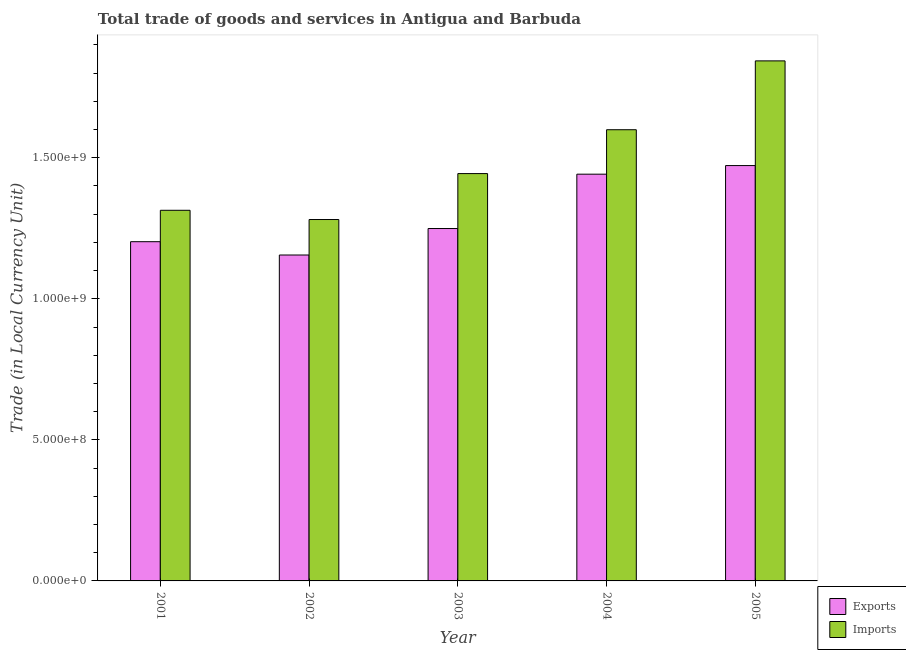How many groups of bars are there?
Offer a terse response. 5. Are the number of bars per tick equal to the number of legend labels?
Your response must be concise. Yes. Are the number of bars on each tick of the X-axis equal?
Make the answer very short. Yes. What is the export of goods and services in 2001?
Ensure brevity in your answer.  1.20e+09. Across all years, what is the maximum imports of goods and services?
Ensure brevity in your answer.  1.84e+09. Across all years, what is the minimum export of goods and services?
Give a very brief answer. 1.16e+09. In which year was the imports of goods and services maximum?
Keep it short and to the point. 2005. What is the total export of goods and services in the graph?
Ensure brevity in your answer.  6.52e+09. What is the difference between the imports of goods and services in 2001 and that in 2004?
Ensure brevity in your answer.  -2.86e+08. What is the difference between the export of goods and services in 2002 and the imports of goods and services in 2004?
Keep it short and to the point. -2.86e+08. What is the average imports of goods and services per year?
Ensure brevity in your answer.  1.50e+09. In the year 2001, what is the difference between the export of goods and services and imports of goods and services?
Make the answer very short. 0. In how many years, is the imports of goods and services greater than 600000000 LCU?
Your answer should be very brief. 5. What is the ratio of the export of goods and services in 2001 to that in 2002?
Offer a very short reply. 1.04. Is the difference between the export of goods and services in 2003 and 2004 greater than the difference between the imports of goods and services in 2003 and 2004?
Provide a short and direct response. No. What is the difference between the highest and the second highest imports of goods and services?
Your answer should be very brief. 2.44e+08. What is the difference between the highest and the lowest imports of goods and services?
Ensure brevity in your answer.  5.62e+08. In how many years, is the imports of goods and services greater than the average imports of goods and services taken over all years?
Give a very brief answer. 2. What does the 2nd bar from the left in 2005 represents?
Provide a succinct answer. Imports. What does the 2nd bar from the right in 2003 represents?
Provide a succinct answer. Exports. Are all the bars in the graph horizontal?
Offer a very short reply. No. How many years are there in the graph?
Keep it short and to the point. 5. How many legend labels are there?
Provide a short and direct response. 2. How are the legend labels stacked?
Offer a terse response. Vertical. What is the title of the graph?
Offer a very short reply. Total trade of goods and services in Antigua and Barbuda. What is the label or title of the X-axis?
Provide a succinct answer. Year. What is the label or title of the Y-axis?
Keep it short and to the point. Trade (in Local Currency Unit). What is the Trade (in Local Currency Unit) of Exports in 2001?
Your response must be concise. 1.20e+09. What is the Trade (in Local Currency Unit) of Imports in 2001?
Your response must be concise. 1.31e+09. What is the Trade (in Local Currency Unit) of Exports in 2002?
Make the answer very short. 1.16e+09. What is the Trade (in Local Currency Unit) of Imports in 2002?
Offer a very short reply. 1.28e+09. What is the Trade (in Local Currency Unit) of Exports in 2003?
Provide a short and direct response. 1.25e+09. What is the Trade (in Local Currency Unit) in Imports in 2003?
Provide a succinct answer. 1.44e+09. What is the Trade (in Local Currency Unit) of Exports in 2004?
Provide a succinct answer. 1.44e+09. What is the Trade (in Local Currency Unit) in Imports in 2004?
Provide a short and direct response. 1.60e+09. What is the Trade (in Local Currency Unit) in Exports in 2005?
Provide a short and direct response. 1.47e+09. What is the Trade (in Local Currency Unit) in Imports in 2005?
Provide a succinct answer. 1.84e+09. Across all years, what is the maximum Trade (in Local Currency Unit) of Exports?
Keep it short and to the point. 1.47e+09. Across all years, what is the maximum Trade (in Local Currency Unit) in Imports?
Offer a very short reply. 1.84e+09. Across all years, what is the minimum Trade (in Local Currency Unit) of Exports?
Provide a succinct answer. 1.16e+09. Across all years, what is the minimum Trade (in Local Currency Unit) in Imports?
Keep it short and to the point. 1.28e+09. What is the total Trade (in Local Currency Unit) of Exports in the graph?
Your answer should be very brief. 6.52e+09. What is the total Trade (in Local Currency Unit) of Imports in the graph?
Keep it short and to the point. 7.48e+09. What is the difference between the Trade (in Local Currency Unit) in Exports in 2001 and that in 2002?
Provide a succinct answer. 4.72e+07. What is the difference between the Trade (in Local Currency Unit) of Imports in 2001 and that in 2002?
Ensure brevity in your answer.  3.28e+07. What is the difference between the Trade (in Local Currency Unit) in Exports in 2001 and that in 2003?
Your response must be concise. -4.67e+07. What is the difference between the Trade (in Local Currency Unit) in Imports in 2001 and that in 2003?
Give a very brief answer. -1.30e+08. What is the difference between the Trade (in Local Currency Unit) of Exports in 2001 and that in 2004?
Give a very brief answer. -2.39e+08. What is the difference between the Trade (in Local Currency Unit) of Imports in 2001 and that in 2004?
Offer a very short reply. -2.86e+08. What is the difference between the Trade (in Local Currency Unit) of Exports in 2001 and that in 2005?
Your answer should be compact. -2.70e+08. What is the difference between the Trade (in Local Currency Unit) in Imports in 2001 and that in 2005?
Offer a very short reply. -5.30e+08. What is the difference between the Trade (in Local Currency Unit) of Exports in 2002 and that in 2003?
Offer a very short reply. -9.39e+07. What is the difference between the Trade (in Local Currency Unit) in Imports in 2002 and that in 2003?
Your answer should be compact. -1.63e+08. What is the difference between the Trade (in Local Currency Unit) of Exports in 2002 and that in 2004?
Offer a very short reply. -2.86e+08. What is the difference between the Trade (in Local Currency Unit) in Imports in 2002 and that in 2004?
Give a very brief answer. -3.18e+08. What is the difference between the Trade (in Local Currency Unit) of Exports in 2002 and that in 2005?
Your response must be concise. -3.17e+08. What is the difference between the Trade (in Local Currency Unit) of Imports in 2002 and that in 2005?
Ensure brevity in your answer.  -5.62e+08. What is the difference between the Trade (in Local Currency Unit) of Exports in 2003 and that in 2004?
Make the answer very short. -1.93e+08. What is the difference between the Trade (in Local Currency Unit) in Imports in 2003 and that in 2004?
Ensure brevity in your answer.  -1.55e+08. What is the difference between the Trade (in Local Currency Unit) in Exports in 2003 and that in 2005?
Provide a short and direct response. -2.23e+08. What is the difference between the Trade (in Local Currency Unit) in Imports in 2003 and that in 2005?
Your response must be concise. -4.00e+08. What is the difference between the Trade (in Local Currency Unit) of Exports in 2004 and that in 2005?
Give a very brief answer. -3.05e+07. What is the difference between the Trade (in Local Currency Unit) of Imports in 2004 and that in 2005?
Keep it short and to the point. -2.44e+08. What is the difference between the Trade (in Local Currency Unit) of Exports in 2001 and the Trade (in Local Currency Unit) of Imports in 2002?
Offer a terse response. -7.86e+07. What is the difference between the Trade (in Local Currency Unit) of Exports in 2001 and the Trade (in Local Currency Unit) of Imports in 2003?
Your answer should be compact. -2.41e+08. What is the difference between the Trade (in Local Currency Unit) of Exports in 2001 and the Trade (in Local Currency Unit) of Imports in 2004?
Provide a succinct answer. -3.97e+08. What is the difference between the Trade (in Local Currency Unit) of Exports in 2001 and the Trade (in Local Currency Unit) of Imports in 2005?
Your answer should be very brief. -6.41e+08. What is the difference between the Trade (in Local Currency Unit) of Exports in 2002 and the Trade (in Local Currency Unit) of Imports in 2003?
Your answer should be very brief. -2.89e+08. What is the difference between the Trade (in Local Currency Unit) in Exports in 2002 and the Trade (in Local Currency Unit) in Imports in 2004?
Ensure brevity in your answer.  -4.44e+08. What is the difference between the Trade (in Local Currency Unit) of Exports in 2002 and the Trade (in Local Currency Unit) of Imports in 2005?
Provide a short and direct response. -6.88e+08. What is the difference between the Trade (in Local Currency Unit) of Exports in 2003 and the Trade (in Local Currency Unit) of Imports in 2004?
Provide a short and direct response. -3.50e+08. What is the difference between the Trade (in Local Currency Unit) in Exports in 2003 and the Trade (in Local Currency Unit) in Imports in 2005?
Your answer should be very brief. -5.94e+08. What is the difference between the Trade (in Local Currency Unit) in Exports in 2004 and the Trade (in Local Currency Unit) in Imports in 2005?
Your answer should be compact. -4.02e+08. What is the average Trade (in Local Currency Unit) in Exports per year?
Provide a short and direct response. 1.30e+09. What is the average Trade (in Local Currency Unit) in Imports per year?
Provide a short and direct response. 1.50e+09. In the year 2001, what is the difference between the Trade (in Local Currency Unit) of Exports and Trade (in Local Currency Unit) of Imports?
Offer a very short reply. -1.11e+08. In the year 2002, what is the difference between the Trade (in Local Currency Unit) of Exports and Trade (in Local Currency Unit) of Imports?
Provide a short and direct response. -1.26e+08. In the year 2003, what is the difference between the Trade (in Local Currency Unit) in Exports and Trade (in Local Currency Unit) in Imports?
Your answer should be compact. -1.95e+08. In the year 2004, what is the difference between the Trade (in Local Currency Unit) in Exports and Trade (in Local Currency Unit) in Imports?
Provide a short and direct response. -1.58e+08. In the year 2005, what is the difference between the Trade (in Local Currency Unit) in Exports and Trade (in Local Currency Unit) in Imports?
Provide a short and direct response. -3.71e+08. What is the ratio of the Trade (in Local Currency Unit) of Exports in 2001 to that in 2002?
Your answer should be very brief. 1.04. What is the ratio of the Trade (in Local Currency Unit) of Imports in 2001 to that in 2002?
Provide a succinct answer. 1.03. What is the ratio of the Trade (in Local Currency Unit) of Exports in 2001 to that in 2003?
Your answer should be very brief. 0.96. What is the ratio of the Trade (in Local Currency Unit) in Imports in 2001 to that in 2003?
Provide a succinct answer. 0.91. What is the ratio of the Trade (in Local Currency Unit) in Exports in 2001 to that in 2004?
Keep it short and to the point. 0.83. What is the ratio of the Trade (in Local Currency Unit) in Imports in 2001 to that in 2004?
Offer a terse response. 0.82. What is the ratio of the Trade (in Local Currency Unit) in Exports in 2001 to that in 2005?
Your answer should be very brief. 0.82. What is the ratio of the Trade (in Local Currency Unit) in Imports in 2001 to that in 2005?
Offer a very short reply. 0.71. What is the ratio of the Trade (in Local Currency Unit) in Exports in 2002 to that in 2003?
Offer a terse response. 0.92. What is the ratio of the Trade (in Local Currency Unit) in Imports in 2002 to that in 2003?
Give a very brief answer. 0.89. What is the ratio of the Trade (in Local Currency Unit) in Exports in 2002 to that in 2004?
Your answer should be compact. 0.8. What is the ratio of the Trade (in Local Currency Unit) in Imports in 2002 to that in 2004?
Ensure brevity in your answer.  0.8. What is the ratio of the Trade (in Local Currency Unit) of Exports in 2002 to that in 2005?
Offer a terse response. 0.78. What is the ratio of the Trade (in Local Currency Unit) in Imports in 2002 to that in 2005?
Make the answer very short. 0.69. What is the ratio of the Trade (in Local Currency Unit) of Exports in 2003 to that in 2004?
Offer a terse response. 0.87. What is the ratio of the Trade (in Local Currency Unit) of Imports in 2003 to that in 2004?
Ensure brevity in your answer.  0.9. What is the ratio of the Trade (in Local Currency Unit) of Exports in 2003 to that in 2005?
Ensure brevity in your answer.  0.85. What is the ratio of the Trade (in Local Currency Unit) of Imports in 2003 to that in 2005?
Give a very brief answer. 0.78. What is the ratio of the Trade (in Local Currency Unit) of Exports in 2004 to that in 2005?
Offer a terse response. 0.98. What is the ratio of the Trade (in Local Currency Unit) in Imports in 2004 to that in 2005?
Your answer should be compact. 0.87. What is the difference between the highest and the second highest Trade (in Local Currency Unit) of Exports?
Your answer should be compact. 3.05e+07. What is the difference between the highest and the second highest Trade (in Local Currency Unit) in Imports?
Offer a terse response. 2.44e+08. What is the difference between the highest and the lowest Trade (in Local Currency Unit) in Exports?
Your answer should be very brief. 3.17e+08. What is the difference between the highest and the lowest Trade (in Local Currency Unit) in Imports?
Offer a very short reply. 5.62e+08. 